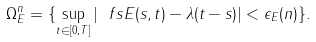Convert formula to latex. <formula><loc_0><loc_0><loc_500><loc_500>\Omega ^ { n } _ { E } = \{ \sup _ { t \in [ 0 , T ] } | \ f s E ( s , t ) - \lambda ( t - s ) | < \epsilon _ { E } ( n ) \} .</formula> 